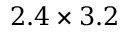<formula> <loc_0><loc_0><loc_500><loc_500>2 . 4 \times 3 . 2</formula> 